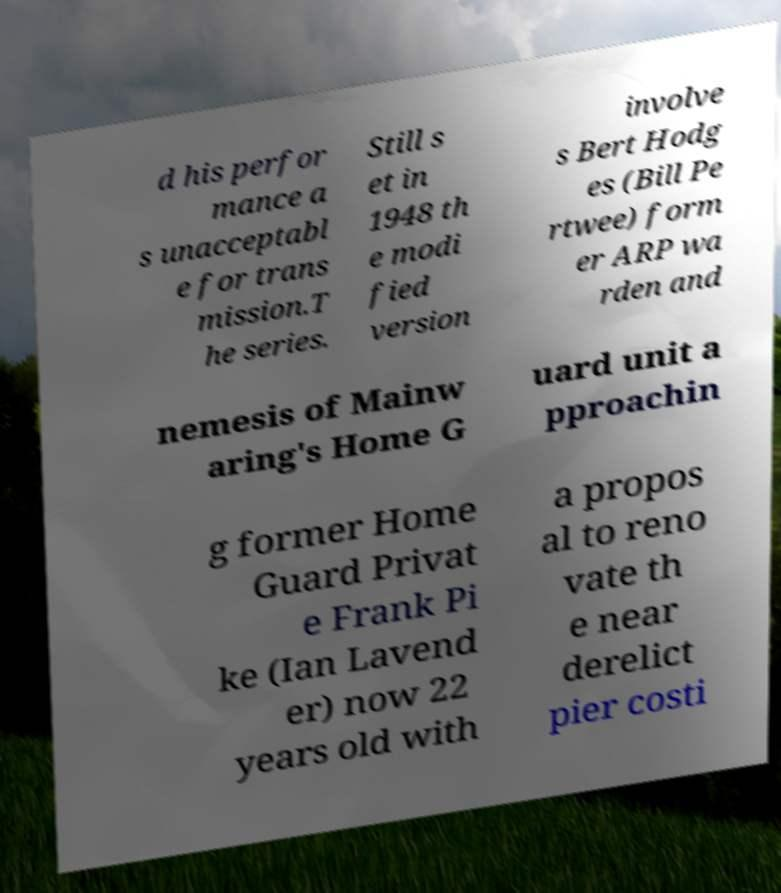Can you read and provide the text displayed in the image?This photo seems to have some interesting text. Can you extract and type it out for me? d his perfor mance a s unacceptabl e for trans mission.T he series. Still s et in 1948 th e modi fied version involve s Bert Hodg es (Bill Pe rtwee) form er ARP wa rden and nemesis of Mainw aring's Home G uard unit a pproachin g former Home Guard Privat e Frank Pi ke (Ian Lavend er) now 22 years old with a propos al to reno vate th e near derelict pier costi 